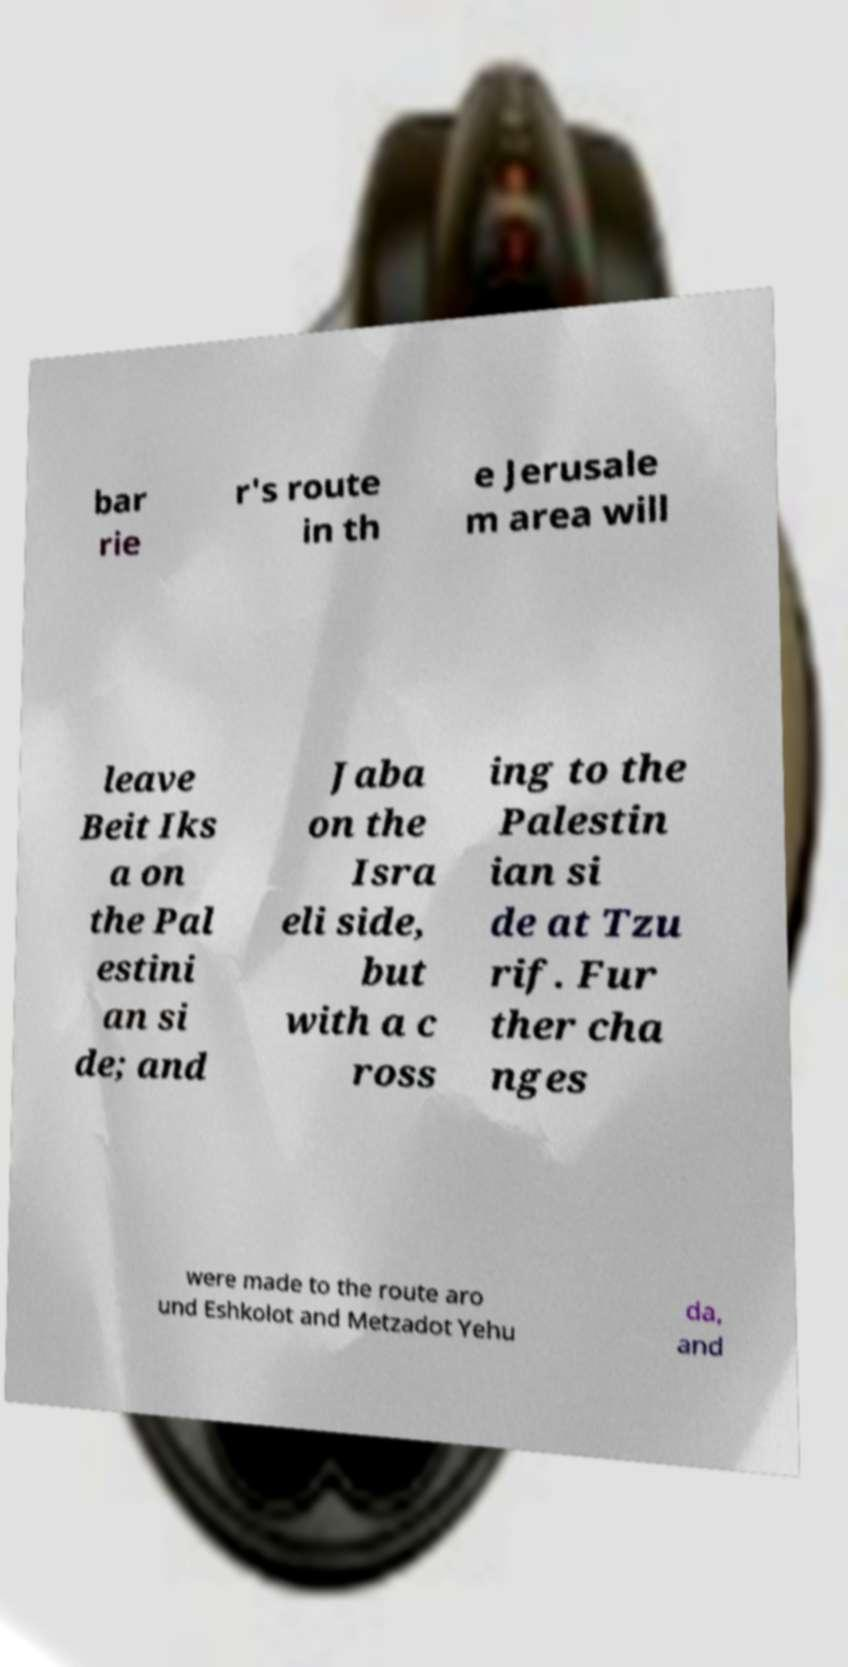I need the written content from this picture converted into text. Can you do that? bar rie r's route in th e Jerusale m area will leave Beit Iks a on the Pal estini an si de; and Jaba on the Isra eli side, but with a c ross ing to the Palestin ian si de at Tzu rif. Fur ther cha nges were made to the route aro und Eshkolot and Metzadot Yehu da, and 